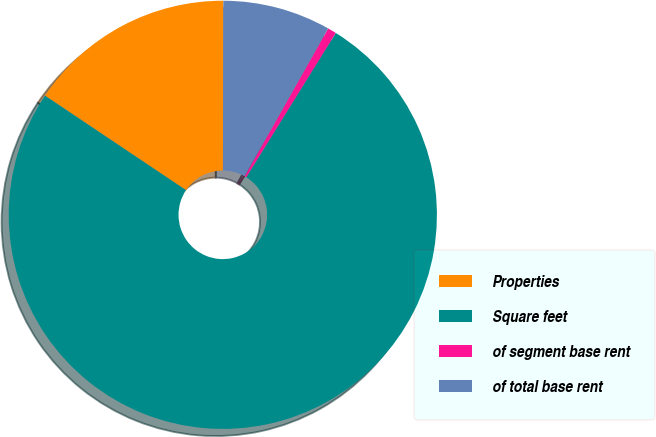Convert chart to OTSL. <chart><loc_0><loc_0><loc_500><loc_500><pie_chart><fcel>Properties<fcel>Square feet<fcel>of segment base rent<fcel>of total base rent<nl><fcel>15.64%<fcel>75.55%<fcel>0.66%<fcel>8.15%<nl></chart> 